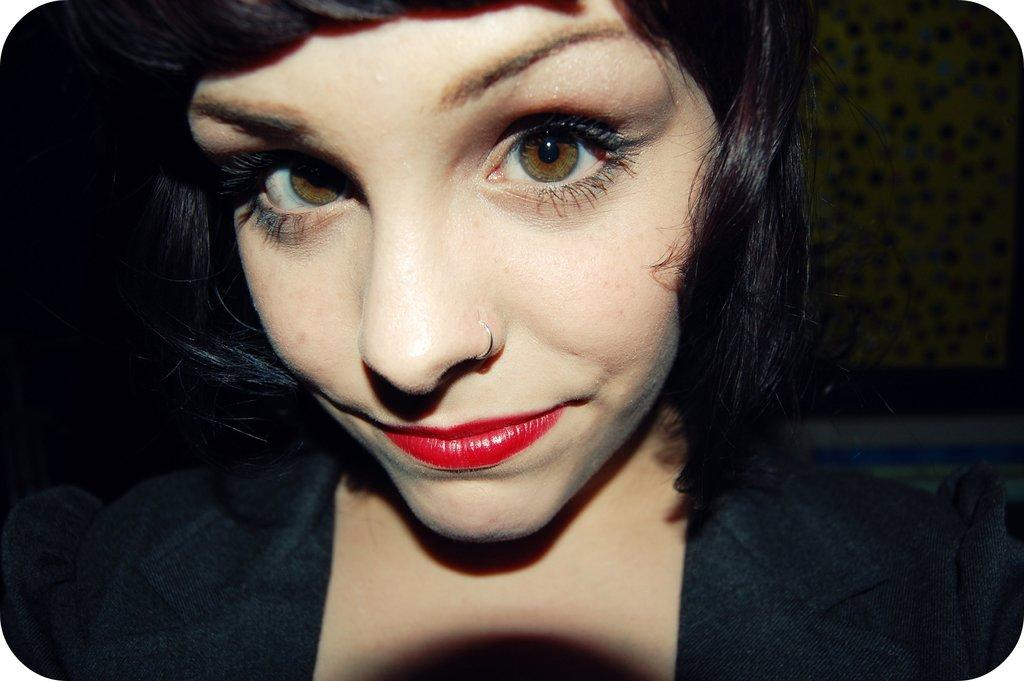Who is the main subject in the image? There is a woman in the image. What is the woman wearing? The woman is wearing a black dress. Where is the woman located in the image? The woman is in the middle of the image. What can be seen in the background of the image? There is a wall in the background of the image. What type of breakfast is being served in the image? There is no breakfast present in the image; it features a woman wearing a black dress in the middle of the image with a wall in the background. 